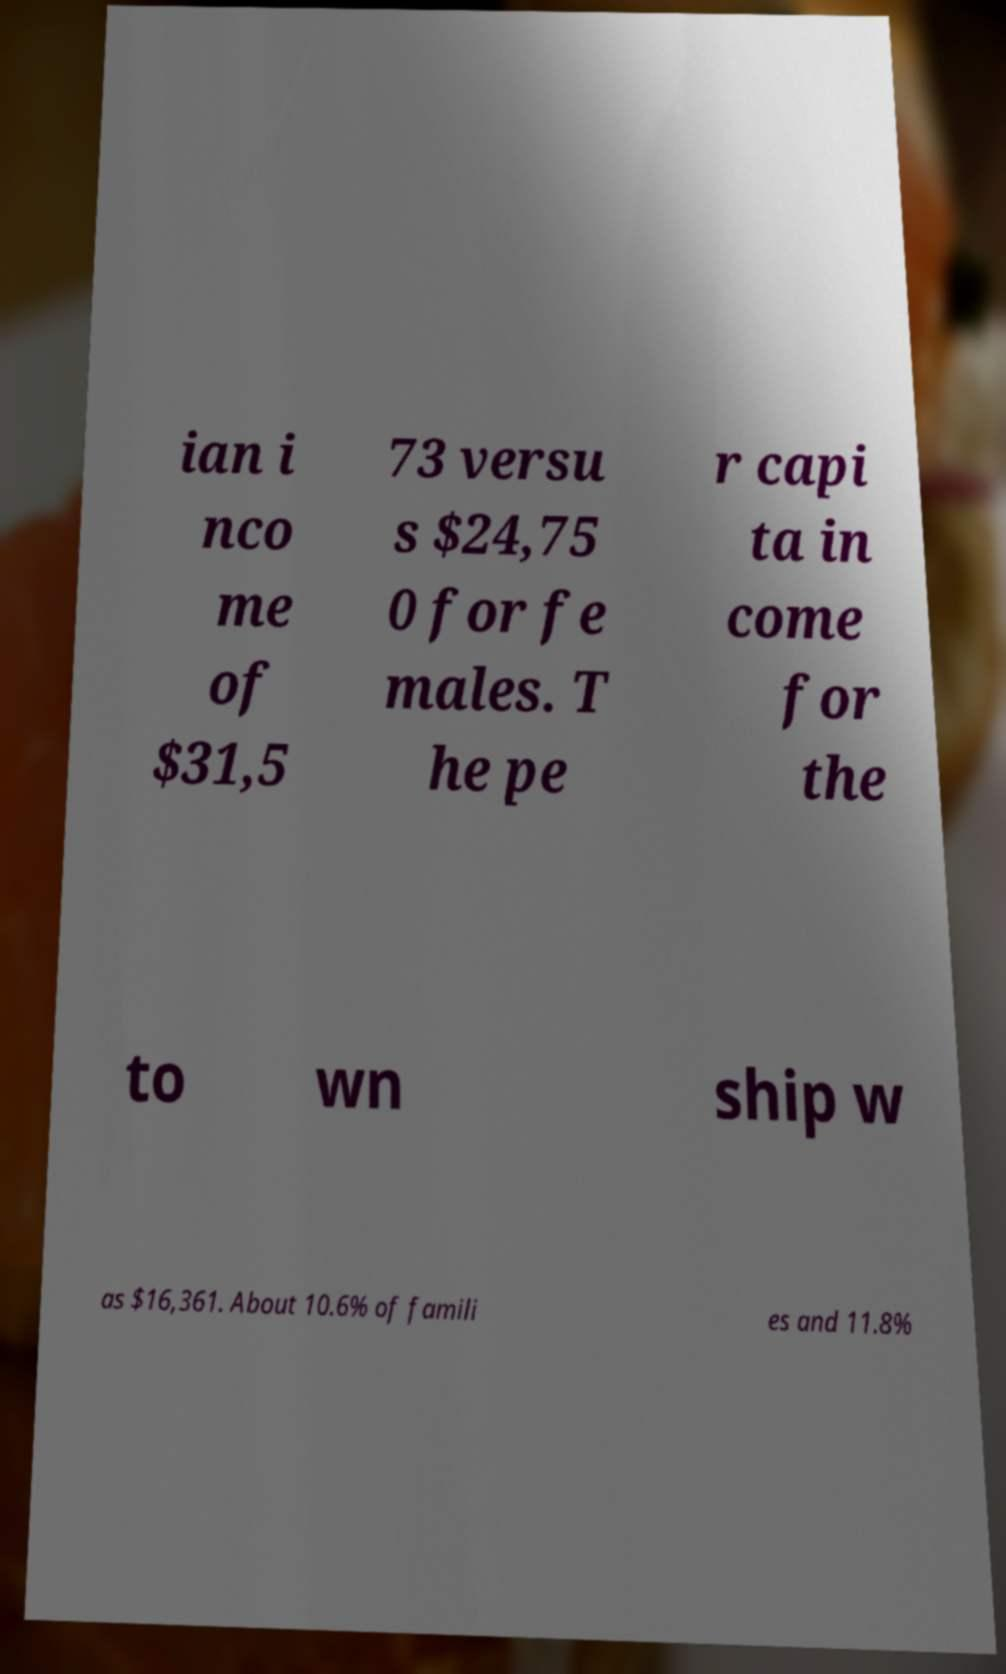I need the written content from this picture converted into text. Can you do that? ian i nco me of $31,5 73 versu s $24,75 0 for fe males. T he pe r capi ta in come for the to wn ship w as $16,361. About 10.6% of famili es and 11.8% 